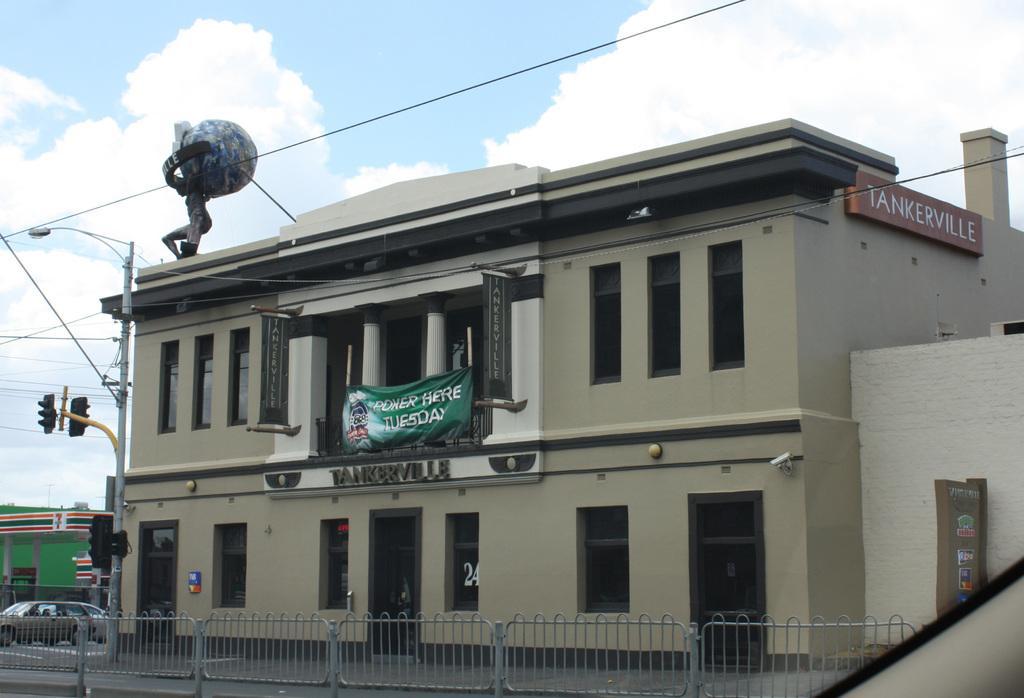Please provide a concise description of this image. In this image there is a building with glass windows and wooden doors, on the building there is a banner and a nameplate, in front of the building there is a metal fence, in front of the building there is a traffic light pole and a lamp post, beside the building there are other buildings and there are cars, at the top of the image there are cables and there are clouds in the sky. 